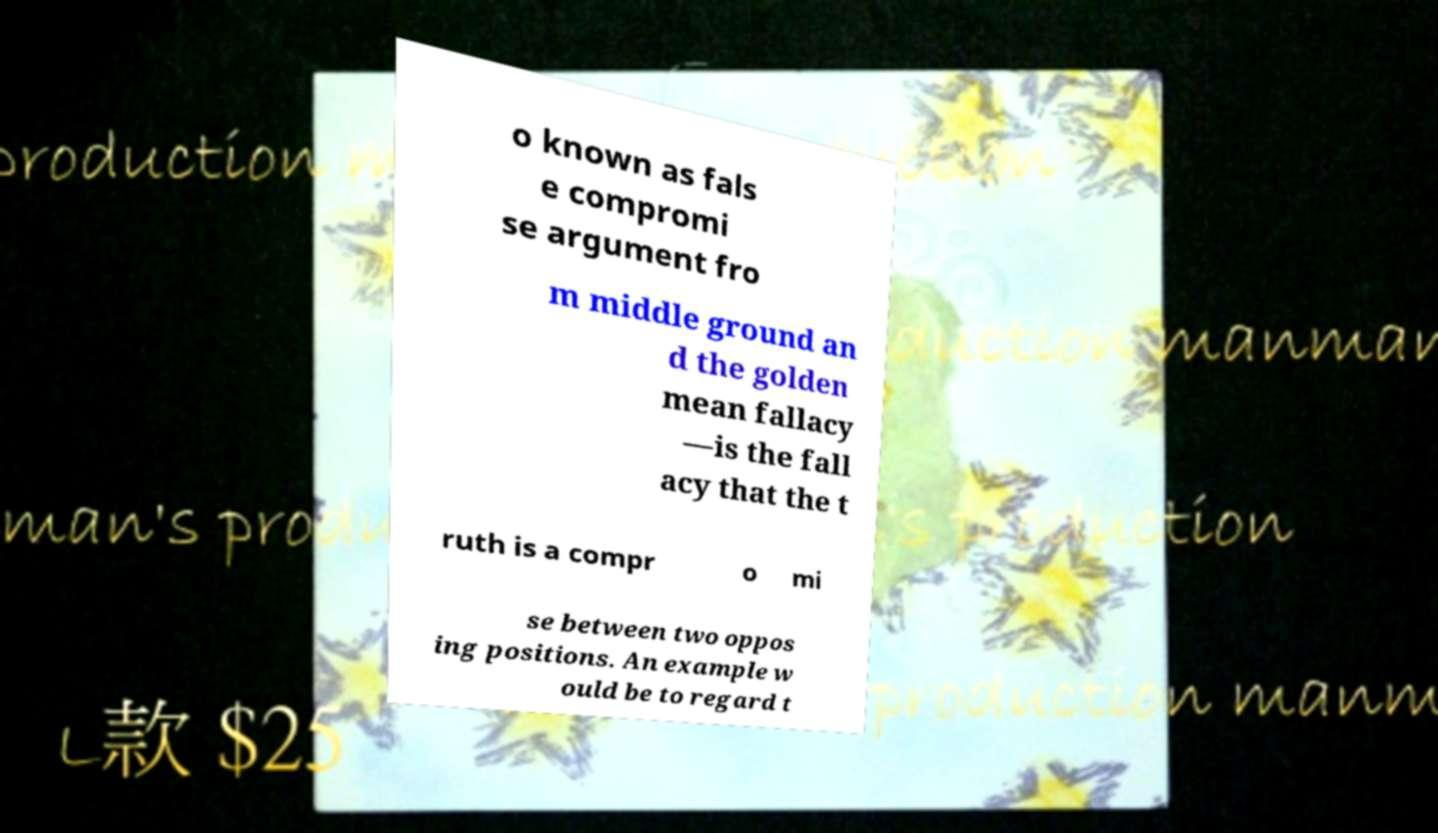Can you accurately transcribe the text from the provided image for me? o known as fals e compromi se argument fro m middle ground an d the golden mean fallacy —is the fall acy that the t ruth is a compr o mi se between two oppos ing positions. An example w ould be to regard t 